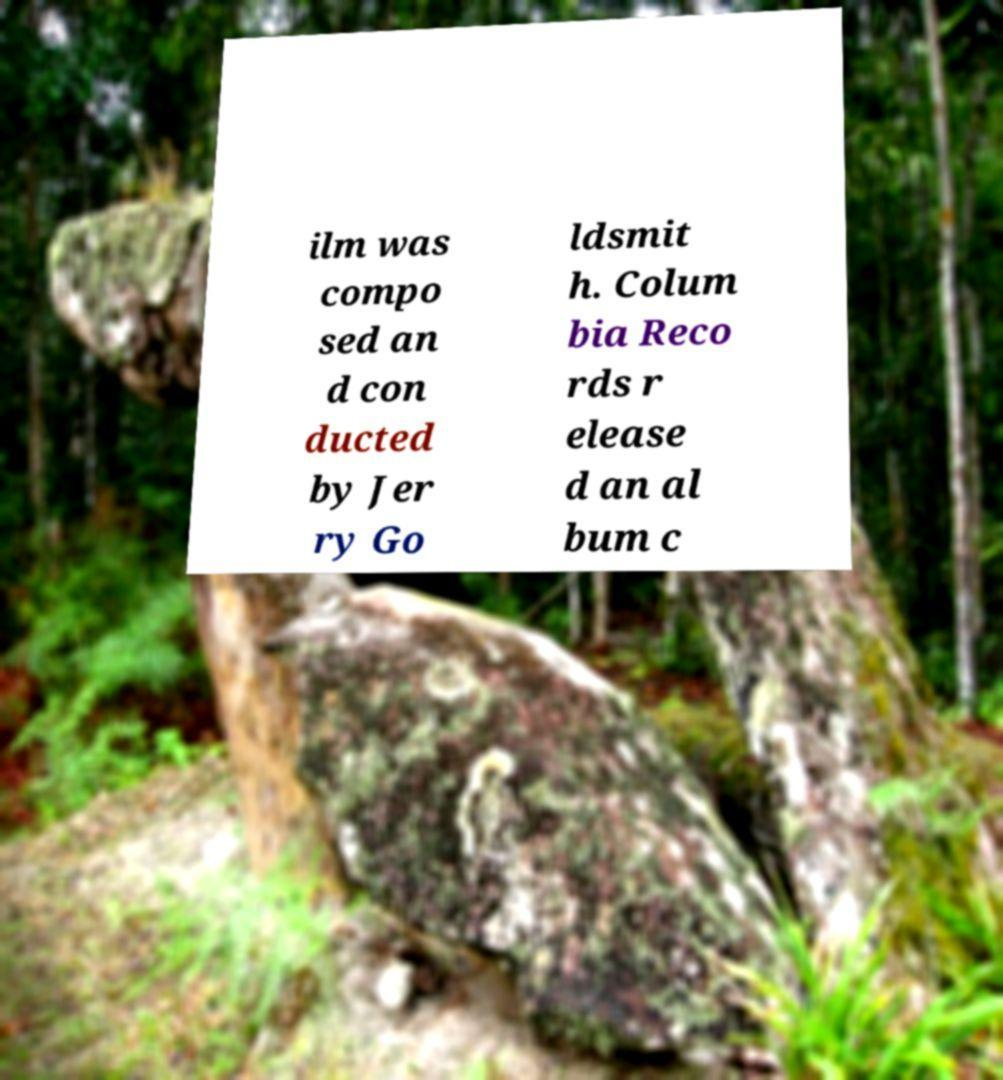Could you assist in decoding the text presented in this image and type it out clearly? ilm was compo sed an d con ducted by Jer ry Go ldsmit h. Colum bia Reco rds r elease d an al bum c 